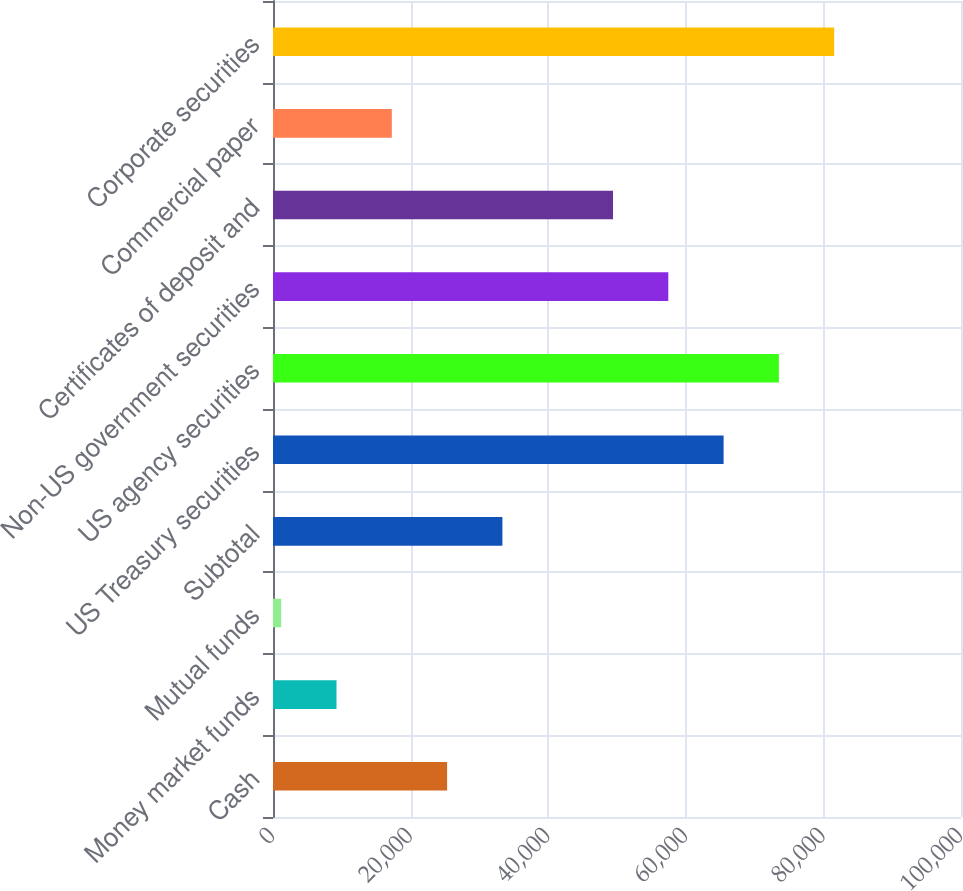Convert chart to OTSL. <chart><loc_0><loc_0><loc_500><loc_500><bar_chart><fcel>Cash<fcel>Money market funds<fcel>Mutual funds<fcel>Subtotal<fcel>US Treasury securities<fcel>US agency securities<fcel>Non-US government securities<fcel>Certificates of deposit and<fcel>Commercial paper<fcel>Corporate securities<nl><fcel>25306.1<fcel>9230.7<fcel>1193<fcel>33343.8<fcel>65494.6<fcel>73532.3<fcel>57456.9<fcel>49419.2<fcel>17268.4<fcel>81570<nl></chart> 